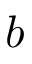Convert formula to latex. <formula><loc_0><loc_0><loc_500><loc_500>b</formula> 